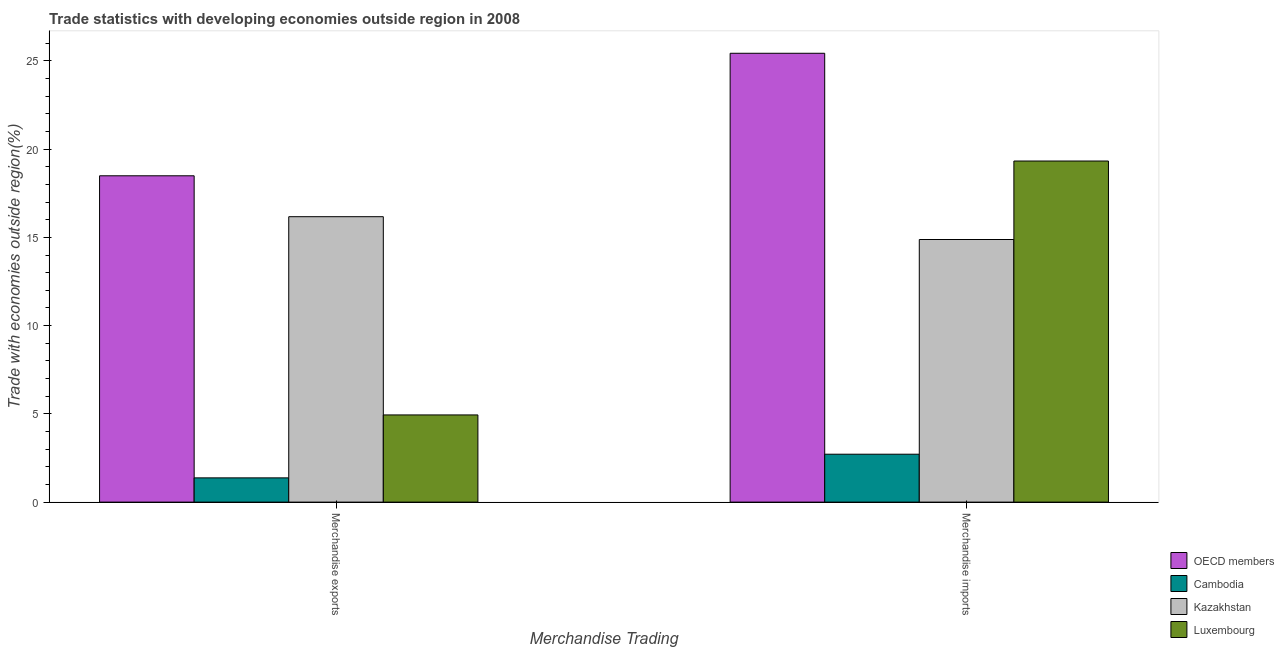How many groups of bars are there?
Provide a short and direct response. 2. Are the number of bars on each tick of the X-axis equal?
Provide a short and direct response. Yes. What is the merchandise imports in Cambodia?
Provide a short and direct response. 2.71. Across all countries, what is the maximum merchandise imports?
Keep it short and to the point. 25.43. Across all countries, what is the minimum merchandise imports?
Provide a short and direct response. 2.71. In which country was the merchandise exports maximum?
Your answer should be very brief. OECD members. In which country was the merchandise exports minimum?
Make the answer very short. Cambodia. What is the total merchandise exports in the graph?
Keep it short and to the point. 40.98. What is the difference between the merchandise imports in OECD members and that in Cambodia?
Provide a short and direct response. 22.72. What is the difference between the merchandise imports in OECD members and the merchandise exports in Cambodia?
Provide a short and direct response. 24.06. What is the average merchandise imports per country?
Your answer should be compact. 15.59. What is the difference between the merchandise exports and merchandise imports in Luxembourg?
Keep it short and to the point. -14.39. In how many countries, is the merchandise imports greater than 24 %?
Offer a very short reply. 1. What is the ratio of the merchandise exports in Cambodia to that in Luxembourg?
Make the answer very short. 0.28. In how many countries, is the merchandise imports greater than the average merchandise imports taken over all countries?
Your answer should be very brief. 2. What does the 3rd bar from the left in Merchandise imports represents?
Provide a succinct answer. Kazakhstan. What does the 3rd bar from the right in Merchandise imports represents?
Offer a very short reply. Cambodia. Are all the bars in the graph horizontal?
Provide a succinct answer. No. How many countries are there in the graph?
Keep it short and to the point. 4. Are the values on the major ticks of Y-axis written in scientific E-notation?
Your answer should be very brief. No. Does the graph contain any zero values?
Your answer should be very brief. No. How are the legend labels stacked?
Ensure brevity in your answer.  Vertical. What is the title of the graph?
Your response must be concise. Trade statistics with developing economies outside region in 2008. Does "Guyana" appear as one of the legend labels in the graph?
Provide a short and direct response. No. What is the label or title of the X-axis?
Make the answer very short. Merchandise Trading. What is the label or title of the Y-axis?
Provide a succinct answer. Trade with economies outside region(%). What is the Trade with economies outside region(%) of OECD members in Merchandise exports?
Your response must be concise. 18.49. What is the Trade with economies outside region(%) in Cambodia in Merchandise exports?
Your response must be concise. 1.37. What is the Trade with economies outside region(%) of Kazakhstan in Merchandise exports?
Make the answer very short. 16.17. What is the Trade with economies outside region(%) in Luxembourg in Merchandise exports?
Your answer should be compact. 4.94. What is the Trade with economies outside region(%) in OECD members in Merchandise imports?
Provide a succinct answer. 25.43. What is the Trade with economies outside region(%) of Cambodia in Merchandise imports?
Your answer should be very brief. 2.71. What is the Trade with economies outside region(%) of Kazakhstan in Merchandise imports?
Your answer should be very brief. 14.88. What is the Trade with economies outside region(%) in Luxembourg in Merchandise imports?
Your answer should be very brief. 19.33. Across all Merchandise Trading, what is the maximum Trade with economies outside region(%) of OECD members?
Offer a terse response. 25.43. Across all Merchandise Trading, what is the maximum Trade with economies outside region(%) in Cambodia?
Provide a short and direct response. 2.71. Across all Merchandise Trading, what is the maximum Trade with economies outside region(%) in Kazakhstan?
Your response must be concise. 16.17. Across all Merchandise Trading, what is the maximum Trade with economies outside region(%) in Luxembourg?
Provide a succinct answer. 19.33. Across all Merchandise Trading, what is the minimum Trade with economies outside region(%) in OECD members?
Provide a succinct answer. 18.49. Across all Merchandise Trading, what is the minimum Trade with economies outside region(%) in Cambodia?
Provide a short and direct response. 1.37. Across all Merchandise Trading, what is the minimum Trade with economies outside region(%) in Kazakhstan?
Offer a terse response. 14.88. Across all Merchandise Trading, what is the minimum Trade with economies outside region(%) in Luxembourg?
Keep it short and to the point. 4.94. What is the total Trade with economies outside region(%) in OECD members in the graph?
Keep it short and to the point. 43.93. What is the total Trade with economies outside region(%) in Cambodia in the graph?
Your response must be concise. 4.09. What is the total Trade with economies outside region(%) in Kazakhstan in the graph?
Make the answer very short. 31.05. What is the total Trade with economies outside region(%) in Luxembourg in the graph?
Keep it short and to the point. 24.27. What is the difference between the Trade with economies outside region(%) in OECD members in Merchandise exports and that in Merchandise imports?
Your response must be concise. -6.94. What is the difference between the Trade with economies outside region(%) in Cambodia in Merchandise exports and that in Merchandise imports?
Offer a very short reply. -1.34. What is the difference between the Trade with economies outside region(%) of Kazakhstan in Merchandise exports and that in Merchandise imports?
Provide a short and direct response. 1.29. What is the difference between the Trade with economies outside region(%) in Luxembourg in Merchandise exports and that in Merchandise imports?
Your response must be concise. -14.39. What is the difference between the Trade with economies outside region(%) in OECD members in Merchandise exports and the Trade with economies outside region(%) in Cambodia in Merchandise imports?
Your answer should be compact. 15.78. What is the difference between the Trade with economies outside region(%) in OECD members in Merchandise exports and the Trade with economies outside region(%) in Kazakhstan in Merchandise imports?
Ensure brevity in your answer.  3.61. What is the difference between the Trade with economies outside region(%) of OECD members in Merchandise exports and the Trade with economies outside region(%) of Luxembourg in Merchandise imports?
Your response must be concise. -0.84. What is the difference between the Trade with economies outside region(%) of Cambodia in Merchandise exports and the Trade with economies outside region(%) of Kazakhstan in Merchandise imports?
Offer a terse response. -13.51. What is the difference between the Trade with economies outside region(%) in Cambodia in Merchandise exports and the Trade with economies outside region(%) in Luxembourg in Merchandise imports?
Provide a short and direct response. -17.95. What is the difference between the Trade with economies outside region(%) in Kazakhstan in Merchandise exports and the Trade with economies outside region(%) in Luxembourg in Merchandise imports?
Offer a terse response. -3.15. What is the average Trade with economies outside region(%) of OECD members per Merchandise Trading?
Ensure brevity in your answer.  21.96. What is the average Trade with economies outside region(%) of Cambodia per Merchandise Trading?
Keep it short and to the point. 2.04. What is the average Trade with economies outside region(%) of Kazakhstan per Merchandise Trading?
Give a very brief answer. 15.53. What is the average Trade with economies outside region(%) in Luxembourg per Merchandise Trading?
Offer a terse response. 12.13. What is the difference between the Trade with economies outside region(%) in OECD members and Trade with economies outside region(%) in Cambodia in Merchandise exports?
Offer a terse response. 17.12. What is the difference between the Trade with economies outside region(%) of OECD members and Trade with economies outside region(%) of Kazakhstan in Merchandise exports?
Provide a succinct answer. 2.32. What is the difference between the Trade with economies outside region(%) in OECD members and Trade with economies outside region(%) in Luxembourg in Merchandise exports?
Your answer should be very brief. 13.55. What is the difference between the Trade with economies outside region(%) in Cambodia and Trade with economies outside region(%) in Kazakhstan in Merchandise exports?
Your answer should be compact. -14.8. What is the difference between the Trade with economies outside region(%) of Cambodia and Trade with economies outside region(%) of Luxembourg in Merchandise exports?
Your response must be concise. -3.57. What is the difference between the Trade with economies outside region(%) of Kazakhstan and Trade with economies outside region(%) of Luxembourg in Merchandise exports?
Provide a short and direct response. 11.23. What is the difference between the Trade with economies outside region(%) in OECD members and Trade with economies outside region(%) in Cambodia in Merchandise imports?
Offer a terse response. 22.72. What is the difference between the Trade with economies outside region(%) of OECD members and Trade with economies outside region(%) of Kazakhstan in Merchandise imports?
Provide a short and direct response. 10.55. What is the difference between the Trade with economies outside region(%) of OECD members and Trade with economies outside region(%) of Luxembourg in Merchandise imports?
Ensure brevity in your answer.  6.11. What is the difference between the Trade with economies outside region(%) in Cambodia and Trade with economies outside region(%) in Kazakhstan in Merchandise imports?
Ensure brevity in your answer.  -12.17. What is the difference between the Trade with economies outside region(%) in Cambodia and Trade with economies outside region(%) in Luxembourg in Merchandise imports?
Make the answer very short. -16.61. What is the difference between the Trade with economies outside region(%) of Kazakhstan and Trade with economies outside region(%) of Luxembourg in Merchandise imports?
Provide a short and direct response. -4.45. What is the ratio of the Trade with economies outside region(%) of OECD members in Merchandise exports to that in Merchandise imports?
Ensure brevity in your answer.  0.73. What is the ratio of the Trade with economies outside region(%) of Cambodia in Merchandise exports to that in Merchandise imports?
Provide a succinct answer. 0.51. What is the ratio of the Trade with economies outside region(%) of Kazakhstan in Merchandise exports to that in Merchandise imports?
Provide a succinct answer. 1.09. What is the ratio of the Trade with economies outside region(%) of Luxembourg in Merchandise exports to that in Merchandise imports?
Make the answer very short. 0.26. What is the difference between the highest and the second highest Trade with economies outside region(%) of OECD members?
Offer a terse response. 6.94. What is the difference between the highest and the second highest Trade with economies outside region(%) of Cambodia?
Provide a succinct answer. 1.34. What is the difference between the highest and the second highest Trade with economies outside region(%) in Kazakhstan?
Provide a succinct answer. 1.29. What is the difference between the highest and the second highest Trade with economies outside region(%) of Luxembourg?
Give a very brief answer. 14.39. What is the difference between the highest and the lowest Trade with economies outside region(%) of OECD members?
Provide a succinct answer. 6.94. What is the difference between the highest and the lowest Trade with economies outside region(%) in Cambodia?
Keep it short and to the point. 1.34. What is the difference between the highest and the lowest Trade with economies outside region(%) in Kazakhstan?
Your answer should be compact. 1.29. What is the difference between the highest and the lowest Trade with economies outside region(%) in Luxembourg?
Offer a very short reply. 14.39. 